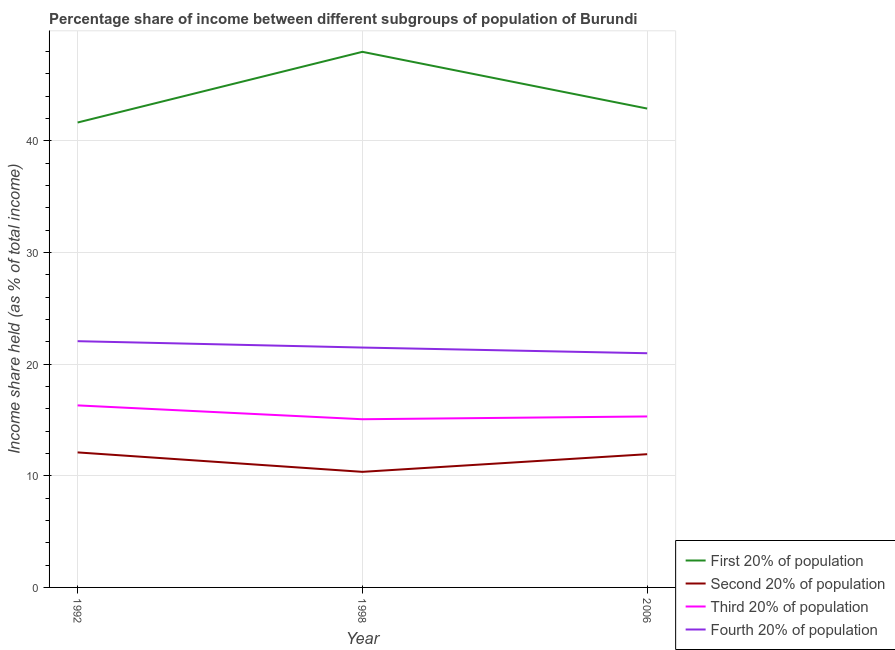Does the line corresponding to share of the income held by second 20% of the population intersect with the line corresponding to share of the income held by third 20% of the population?
Make the answer very short. No. What is the share of the income held by first 20% of the population in 1998?
Make the answer very short. 47.96. Across all years, what is the maximum share of the income held by fourth 20% of the population?
Your answer should be very brief. 22.05. Across all years, what is the minimum share of the income held by third 20% of the population?
Make the answer very short. 15.06. In which year was the share of the income held by second 20% of the population maximum?
Ensure brevity in your answer.  1992. In which year was the share of the income held by first 20% of the population minimum?
Make the answer very short. 1992. What is the total share of the income held by first 20% of the population in the graph?
Your answer should be very brief. 132.47. What is the difference between the share of the income held by first 20% of the population in 1998 and that in 2006?
Make the answer very short. 5.08. What is the difference between the share of the income held by first 20% of the population in 1998 and the share of the income held by third 20% of the population in 2006?
Ensure brevity in your answer.  32.65. In the year 1992, what is the difference between the share of the income held by third 20% of the population and share of the income held by fourth 20% of the population?
Give a very brief answer. -5.75. What is the ratio of the share of the income held by second 20% of the population in 1998 to that in 2006?
Make the answer very short. 0.87. Is the share of the income held by first 20% of the population in 1998 less than that in 2006?
Your response must be concise. No. Is the difference between the share of the income held by third 20% of the population in 1998 and 2006 greater than the difference between the share of the income held by fourth 20% of the population in 1998 and 2006?
Provide a short and direct response. No. What is the difference between the highest and the second highest share of the income held by fourth 20% of the population?
Provide a short and direct response. 0.57. What is the difference between the highest and the lowest share of the income held by third 20% of the population?
Ensure brevity in your answer.  1.24. In how many years, is the share of the income held by second 20% of the population greater than the average share of the income held by second 20% of the population taken over all years?
Keep it short and to the point. 2. Is the sum of the share of the income held by second 20% of the population in 1998 and 2006 greater than the maximum share of the income held by third 20% of the population across all years?
Make the answer very short. Yes. Is it the case that in every year, the sum of the share of the income held by fourth 20% of the population and share of the income held by first 20% of the population is greater than the sum of share of the income held by third 20% of the population and share of the income held by second 20% of the population?
Your answer should be very brief. Yes. Is it the case that in every year, the sum of the share of the income held by first 20% of the population and share of the income held by second 20% of the population is greater than the share of the income held by third 20% of the population?
Your answer should be compact. Yes. Does the share of the income held by first 20% of the population monotonically increase over the years?
Provide a succinct answer. No. Is the share of the income held by fourth 20% of the population strictly greater than the share of the income held by third 20% of the population over the years?
Provide a succinct answer. Yes. How many years are there in the graph?
Offer a very short reply. 3. What is the difference between two consecutive major ticks on the Y-axis?
Ensure brevity in your answer.  10. Are the values on the major ticks of Y-axis written in scientific E-notation?
Make the answer very short. No. Does the graph contain grids?
Give a very brief answer. Yes. How are the legend labels stacked?
Keep it short and to the point. Vertical. What is the title of the graph?
Make the answer very short. Percentage share of income between different subgroups of population of Burundi. Does "Secondary vocational" appear as one of the legend labels in the graph?
Give a very brief answer. No. What is the label or title of the X-axis?
Offer a very short reply. Year. What is the label or title of the Y-axis?
Keep it short and to the point. Income share held (as % of total income). What is the Income share held (as % of total income) of First 20% of population in 1992?
Keep it short and to the point. 41.63. What is the Income share held (as % of total income) of Second 20% of population in 1992?
Provide a short and direct response. 12.09. What is the Income share held (as % of total income) of Fourth 20% of population in 1992?
Your response must be concise. 22.05. What is the Income share held (as % of total income) of First 20% of population in 1998?
Keep it short and to the point. 47.96. What is the Income share held (as % of total income) of Second 20% of population in 1998?
Offer a very short reply. 10.35. What is the Income share held (as % of total income) of Third 20% of population in 1998?
Your answer should be compact. 15.06. What is the Income share held (as % of total income) in Fourth 20% of population in 1998?
Provide a succinct answer. 21.48. What is the Income share held (as % of total income) of First 20% of population in 2006?
Offer a very short reply. 42.88. What is the Income share held (as % of total income) of Second 20% of population in 2006?
Your response must be concise. 11.93. What is the Income share held (as % of total income) in Third 20% of population in 2006?
Your answer should be compact. 15.31. What is the Income share held (as % of total income) of Fourth 20% of population in 2006?
Make the answer very short. 20.97. Across all years, what is the maximum Income share held (as % of total income) of First 20% of population?
Your answer should be very brief. 47.96. Across all years, what is the maximum Income share held (as % of total income) of Second 20% of population?
Make the answer very short. 12.09. Across all years, what is the maximum Income share held (as % of total income) in Fourth 20% of population?
Your response must be concise. 22.05. Across all years, what is the minimum Income share held (as % of total income) of First 20% of population?
Provide a succinct answer. 41.63. Across all years, what is the minimum Income share held (as % of total income) in Second 20% of population?
Ensure brevity in your answer.  10.35. Across all years, what is the minimum Income share held (as % of total income) of Third 20% of population?
Make the answer very short. 15.06. Across all years, what is the minimum Income share held (as % of total income) in Fourth 20% of population?
Make the answer very short. 20.97. What is the total Income share held (as % of total income) in First 20% of population in the graph?
Your response must be concise. 132.47. What is the total Income share held (as % of total income) of Second 20% of population in the graph?
Keep it short and to the point. 34.37. What is the total Income share held (as % of total income) in Third 20% of population in the graph?
Provide a succinct answer. 46.67. What is the total Income share held (as % of total income) in Fourth 20% of population in the graph?
Your answer should be compact. 64.5. What is the difference between the Income share held (as % of total income) in First 20% of population in 1992 and that in 1998?
Provide a succinct answer. -6.33. What is the difference between the Income share held (as % of total income) of Second 20% of population in 1992 and that in 1998?
Provide a short and direct response. 1.74. What is the difference between the Income share held (as % of total income) in Third 20% of population in 1992 and that in 1998?
Keep it short and to the point. 1.24. What is the difference between the Income share held (as % of total income) in Fourth 20% of population in 1992 and that in 1998?
Make the answer very short. 0.57. What is the difference between the Income share held (as % of total income) of First 20% of population in 1992 and that in 2006?
Ensure brevity in your answer.  -1.25. What is the difference between the Income share held (as % of total income) of Second 20% of population in 1992 and that in 2006?
Offer a terse response. 0.16. What is the difference between the Income share held (as % of total income) of Fourth 20% of population in 1992 and that in 2006?
Keep it short and to the point. 1.08. What is the difference between the Income share held (as % of total income) of First 20% of population in 1998 and that in 2006?
Your answer should be compact. 5.08. What is the difference between the Income share held (as % of total income) of Second 20% of population in 1998 and that in 2006?
Make the answer very short. -1.58. What is the difference between the Income share held (as % of total income) of Third 20% of population in 1998 and that in 2006?
Make the answer very short. -0.25. What is the difference between the Income share held (as % of total income) of Fourth 20% of population in 1998 and that in 2006?
Provide a succinct answer. 0.51. What is the difference between the Income share held (as % of total income) in First 20% of population in 1992 and the Income share held (as % of total income) in Second 20% of population in 1998?
Provide a succinct answer. 31.28. What is the difference between the Income share held (as % of total income) in First 20% of population in 1992 and the Income share held (as % of total income) in Third 20% of population in 1998?
Ensure brevity in your answer.  26.57. What is the difference between the Income share held (as % of total income) of First 20% of population in 1992 and the Income share held (as % of total income) of Fourth 20% of population in 1998?
Offer a very short reply. 20.15. What is the difference between the Income share held (as % of total income) in Second 20% of population in 1992 and the Income share held (as % of total income) in Third 20% of population in 1998?
Your answer should be very brief. -2.97. What is the difference between the Income share held (as % of total income) in Second 20% of population in 1992 and the Income share held (as % of total income) in Fourth 20% of population in 1998?
Make the answer very short. -9.39. What is the difference between the Income share held (as % of total income) in Third 20% of population in 1992 and the Income share held (as % of total income) in Fourth 20% of population in 1998?
Offer a terse response. -5.18. What is the difference between the Income share held (as % of total income) of First 20% of population in 1992 and the Income share held (as % of total income) of Second 20% of population in 2006?
Provide a succinct answer. 29.7. What is the difference between the Income share held (as % of total income) in First 20% of population in 1992 and the Income share held (as % of total income) in Third 20% of population in 2006?
Make the answer very short. 26.32. What is the difference between the Income share held (as % of total income) of First 20% of population in 1992 and the Income share held (as % of total income) of Fourth 20% of population in 2006?
Provide a succinct answer. 20.66. What is the difference between the Income share held (as % of total income) of Second 20% of population in 1992 and the Income share held (as % of total income) of Third 20% of population in 2006?
Provide a succinct answer. -3.22. What is the difference between the Income share held (as % of total income) of Second 20% of population in 1992 and the Income share held (as % of total income) of Fourth 20% of population in 2006?
Your answer should be very brief. -8.88. What is the difference between the Income share held (as % of total income) in Third 20% of population in 1992 and the Income share held (as % of total income) in Fourth 20% of population in 2006?
Make the answer very short. -4.67. What is the difference between the Income share held (as % of total income) in First 20% of population in 1998 and the Income share held (as % of total income) in Second 20% of population in 2006?
Make the answer very short. 36.03. What is the difference between the Income share held (as % of total income) in First 20% of population in 1998 and the Income share held (as % of total income) in Third 20% of population in 2006?
Make the answer very short. 32.65. What is the difference between the Income share held (as % of total income) of First 20% of population in 1998 and the Income share held (as % of total income) of Fourth 20% of population in 2006?
Provide a succinct answer. 26.99. What is the difference between the Income share held (as % of total income) in Second 20% of population in 1998 and the Income share held (as % of total income) in Third 20% of population in 2006?
Make the answer very short. -4.96. What is the difference between the Income share held (as % of total income) in Second 20% of population in 1998 and the Income share held (as % of total income) in Fourth 20% of population in 2006?
Give a very brief answer. -10.62. What is the difference between the Income share held (as % of total income) of Third 20% of population in 1998 and the Income share held (as % of total income) of Fourth 20% of population in 2006?
Your answer should be compact. -5.91. What is the average Income share held (as % of total income) in First 20% of population per year?
Keep it short and to the point. 44.16. What is the average Income share held (as % of total income) in Second 20% of population per year?
Keep it short and to the point. 11.46. What is the average Income share held (as % of total income) in Third 20% of population per year?
Keep it short and to the point. 15.56. In the year 1992, what is the difference between the Income share held (as % of total income) in First 20% of population and Income share held (as % of total income) in Second 20% of population?
Make the answer very short. 29.54. In the year 1992, what is the difference between the Income share held (as % of total income) in First 20% of population and Income share held (as % of total income) in Third 20% of population?
Ensure brevity in your answer.  25.33. In the year 1992, what is the difference between the Income share held (as % of total income) in First 20% of population and Income share held (as % of total income) in Fourth 20% of population?
Your answer should be compact. 19.58. In the year 1992, what is the difference between the Income share held (as % of total income) in Second 20% of population and Income share held (as % of total income) in Third 20% of population?
Ensure brevity in your answer.  -4.21. In the year 1992, what is the difference between the Income share held (as % of total income) of Second 20% of population and Income share held (as % of total income) of Fourth 20% of population?
Give a very brief answer. -9.96. In the year 1992, what is the difference between the Income share held (as % of total income) of Third 20% of population and Income share held (as % of total income) of Fourth 20% of population?
Your answer should be compact. -5.75. In the year 1998, what is the difference between the Income share held (as % of total income) of First 20% of population and Income share held (as % of total income) of Second 20% of population?
Provide a succinct answer. 37.61. In the year 1998, what is the difference between the Income share held (as % of total income) of First 20% of population and Income share held (as % of total income) of Third 20% of population?
Ensure brevity in your answer.  32.9. In the year 1998, what is the difference between the Income share held (as % of total income) of First 20% of population and Income share held (as % of total income) of Fourth 20% of population?
Keep it short and to the point. 26.48. In the year 1998, what is the difference between the Income share held (as % of total income) of Second 20% of population and Income share held (as % of total income) of Third 20% of population?
Your answer should be compact. -4.71. In the year 1998, what is the difference between the Income share held (as % of total income) in Second 20% of population and Income share held (as % of total income) in Fourth 20% of population?
Ensure brevity in your answer.  -11.13. In the year 1998, what is the difference between the Income share held (as % of total income) of Third 20% of population and Income share held (as % of total income) of Fourth 20% of population?
Keep it short and to the point. -6.42. In the year 2006, what is the difference between the Income share held (as % of total income) in First 20% of population and Income share held (as % of total income) in Second 20% of population?
Offer a terse response. 30.95. In the year 2006, what is the difference between the Income share held (as % of total income) of First 20% of population and Income share held (as % of total income) of Third 20% of population?
Provide a succinct answer. 27.57. In the year 2006, what is the difference between the Income share held (as % of total income) in First 20% of population and Income share held (as % of total income) in Fourth 20% of population?
Offer a terse response. 21.91. In the year 2006, what is the difference between the Income share held (as % of total income) in Second 20% of population and Income share held (as % of total income) in Third 20% of population?
Your answer should be compact. -3.38. In the year 2006, what is the difference between the Income share held (as % of total income) in Second 20% of population and Income share held (as % of total income) in Fourth 20% of population?
Offer a very short reply. -9.04. In the year 2006, what is the difference between the Income share held (as % of total income) in Third 20% of population and Income share held (as % of total income) in Fourth 20% of population?
Provide a succinct answer. -5.66. What is the ratio of the Income share held (as % of total income) in First 20% of population in 1992 to that in 1998?
Provide a succinct answer. 0.87. What is the ratio of the Income share held (as % of total income) in Second 20% of population in 1992 to that in 1998?
Provide a short and direct response. 1.17. What is the ratio of the Income share held (as % of total income) in Third 20% of population in 1992 to that in 1998?
Ensure brevity in your answer.  1.08. What is the ratio of the Income share held (as % of total income) of Fourth 20% of population in 1992 to that in 1998?
Provide a succinct answer. 1.03. What is the ratio of the Income share held (as % of total income) of First 20% of population in 1992 to that in 2006?
Your answer should be very brief. 0.97. What is the ratio of the Income share held (as % of total income) of Second 20% of population in 1992 to that in 2006?
Your response must be concise. 1.01. What is the ratio of the Income share held (as % of total income) in Third 20% of population in 1992 to that in 2006?
Give a very brief answer. 1.06. What is the ratio of the Income share held (as % of total income) in Fourth 20% of population in 1992 to that in 2006?
Provide a succinct answer. 1.05. What is the ratio of the Income share held (as % of total income) in First 20% of population in 1998 to that in 2006?
Your answer should be compact. 1.12. What is the ratio of the Income share held (as % of total income) of Second 20% of population in 1998 to that in 2006?
Make the answer very short. 0.87. What is the ratio of the Income share held (as % of total income) in Third 20% of population in 1998 to that in 2006?
Offer a terse response. 0.98. What is the ratio of the Income share held (as % of total income) in Fourth 20% of population in 1998 to that in 2006?
Keep it short and to the point. 1.02. What is the difference between the highest and the second highest Income share held (as % of total income) of First 20% of population?
Give a very brief answer. 5.08. What is the difference between the highest and the second highest Income share held (as % of total income) of Second 20% of population?
Make the answer very short. 0.16. What is the difference between the highest and the second highest Income share held (as % of total income) of Fourth 20% of population?
Give a very brief answer. 0.57. What is the difference between the highest and the lowest Income share held (as % of total income) of First 20% of population?
Offer a terse response. 6.33. What is the difference between the highest and the lowest Income share held (as % of total income) in Second 20% of population?
Your answer should be compact. 1.74. What is the difference between the highest and the lowest Income share held (as % of total income) in Third 20% of population?
Offer a very short reply. 1.24. What is the difference between the highest and the lowest Income share held (as % of total income) of Fourth 20% of population?
Offer a very short reply. 1.08. 